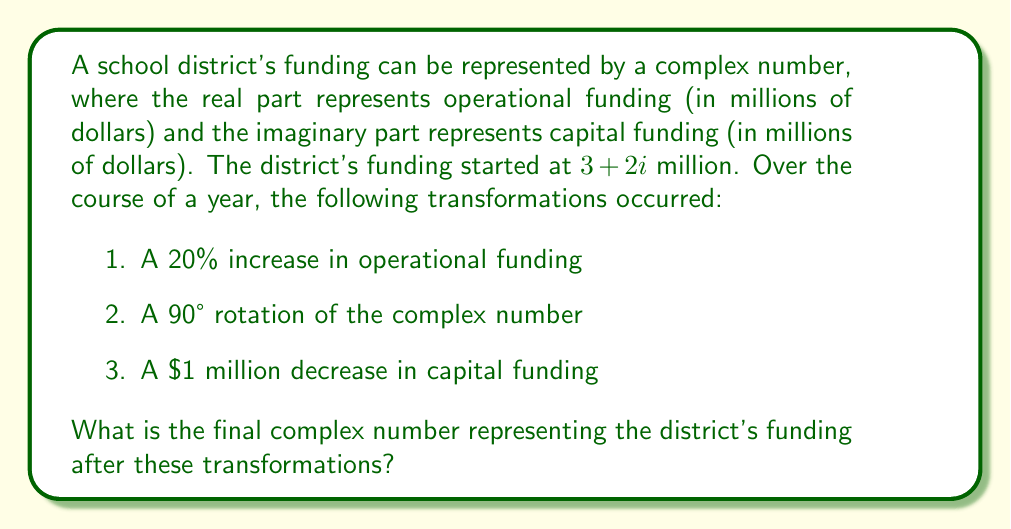Could you help me with this problem? Let's approach this step-by-step:

1. Initial funding: $z = 3 + 2i$ million

2. 20% increase in operational funding:
   $z_1 = (3 \cdot 1.2) + 2i = 3.6 + 2i$ million

3. 90° rotation of the complex number:
   A 90° rotation is equivalent to multiplying by $i$:
   $z_2 = (3.6 + 2i) \cdot i = 3.6i - 2 = -2 + 3.6i$ million

4. $1 million decrease in capital funding:
   $z_3 = -2 + (3.6 - 1)i = -2 + 2.6i$ million

Therefore, the final complex number representing the district's funding is $-2 + 2.6i$ million.
Answer: $-2 + 2.6i$ million 